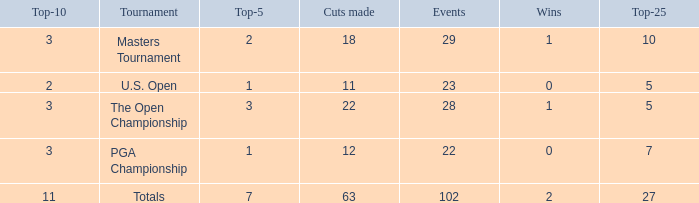How many top 10s associated with 3 top 5s and under 22 cuts made? None. 